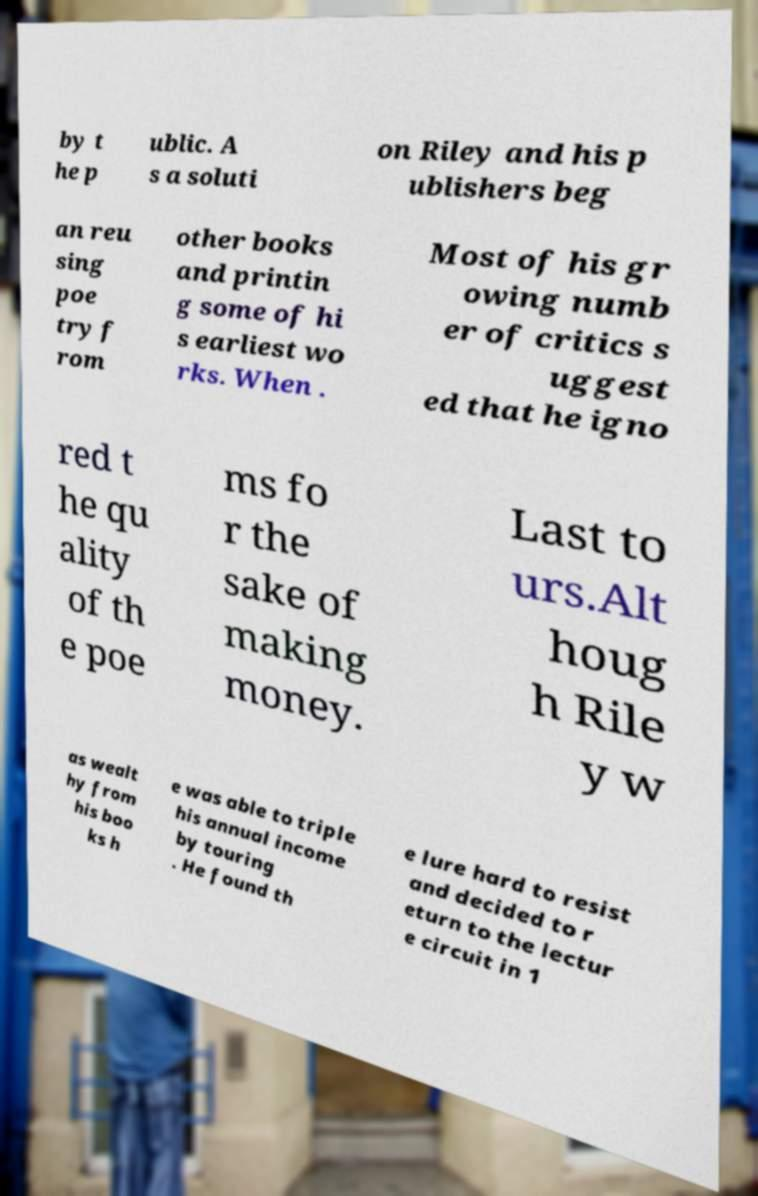For documentation purposes, I need the text within this image transcribed. Could you provide that? by t he p ublic. A s a soluti on Riley and his p ublishers beg an reu sing poe try f rom other books and printin g some of hi s earliest wo rks. When . Most of his gr owing numb er of critics s uggest ed that he igno red t he qu ality of th e poe ms fo r the sake of making money. Last to urs.Alt houg h Rile y w as wealt hy from his boo ks h e was able to triple his annual income by touring . He found th e lure hard to resist and decided to r eturn to the lectur e circuit in 1 